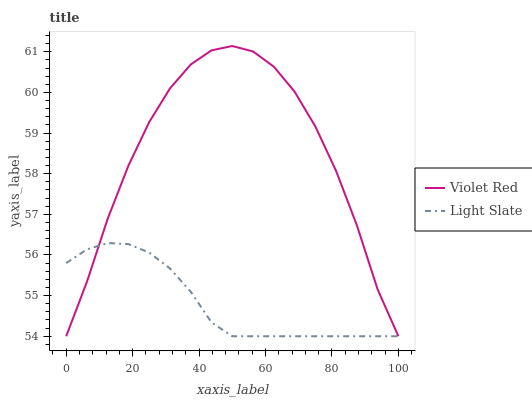Does Light Slate have the minimum area under the curve?
Answer yes or no. Yes. Does Violet Red have the maximum area under the curve?
Answer yes or no. Yes. Does Violet Red have the minimum area under the curve?
Answer yes or no. No. Is Light Slate the smoothest?
Answer yes or no. Yes. Is Violet Red the roughest?
Answer yes or no. Yes. Is Violet Red the smoothest?
Answer yes or no. No. Does Light Slate have the lowest value?
Answer yes or no. Yes. Does Violet Red have the highest value?
Answer yes or no. Yes. Does Light Slate intersect Violet Red?
Answer yes or no. Yes. Is Light Slate less than Violet Red?
Answer yes or no. No. Is Light Slate greater than Violet Red?
Answer yes or no. No. 